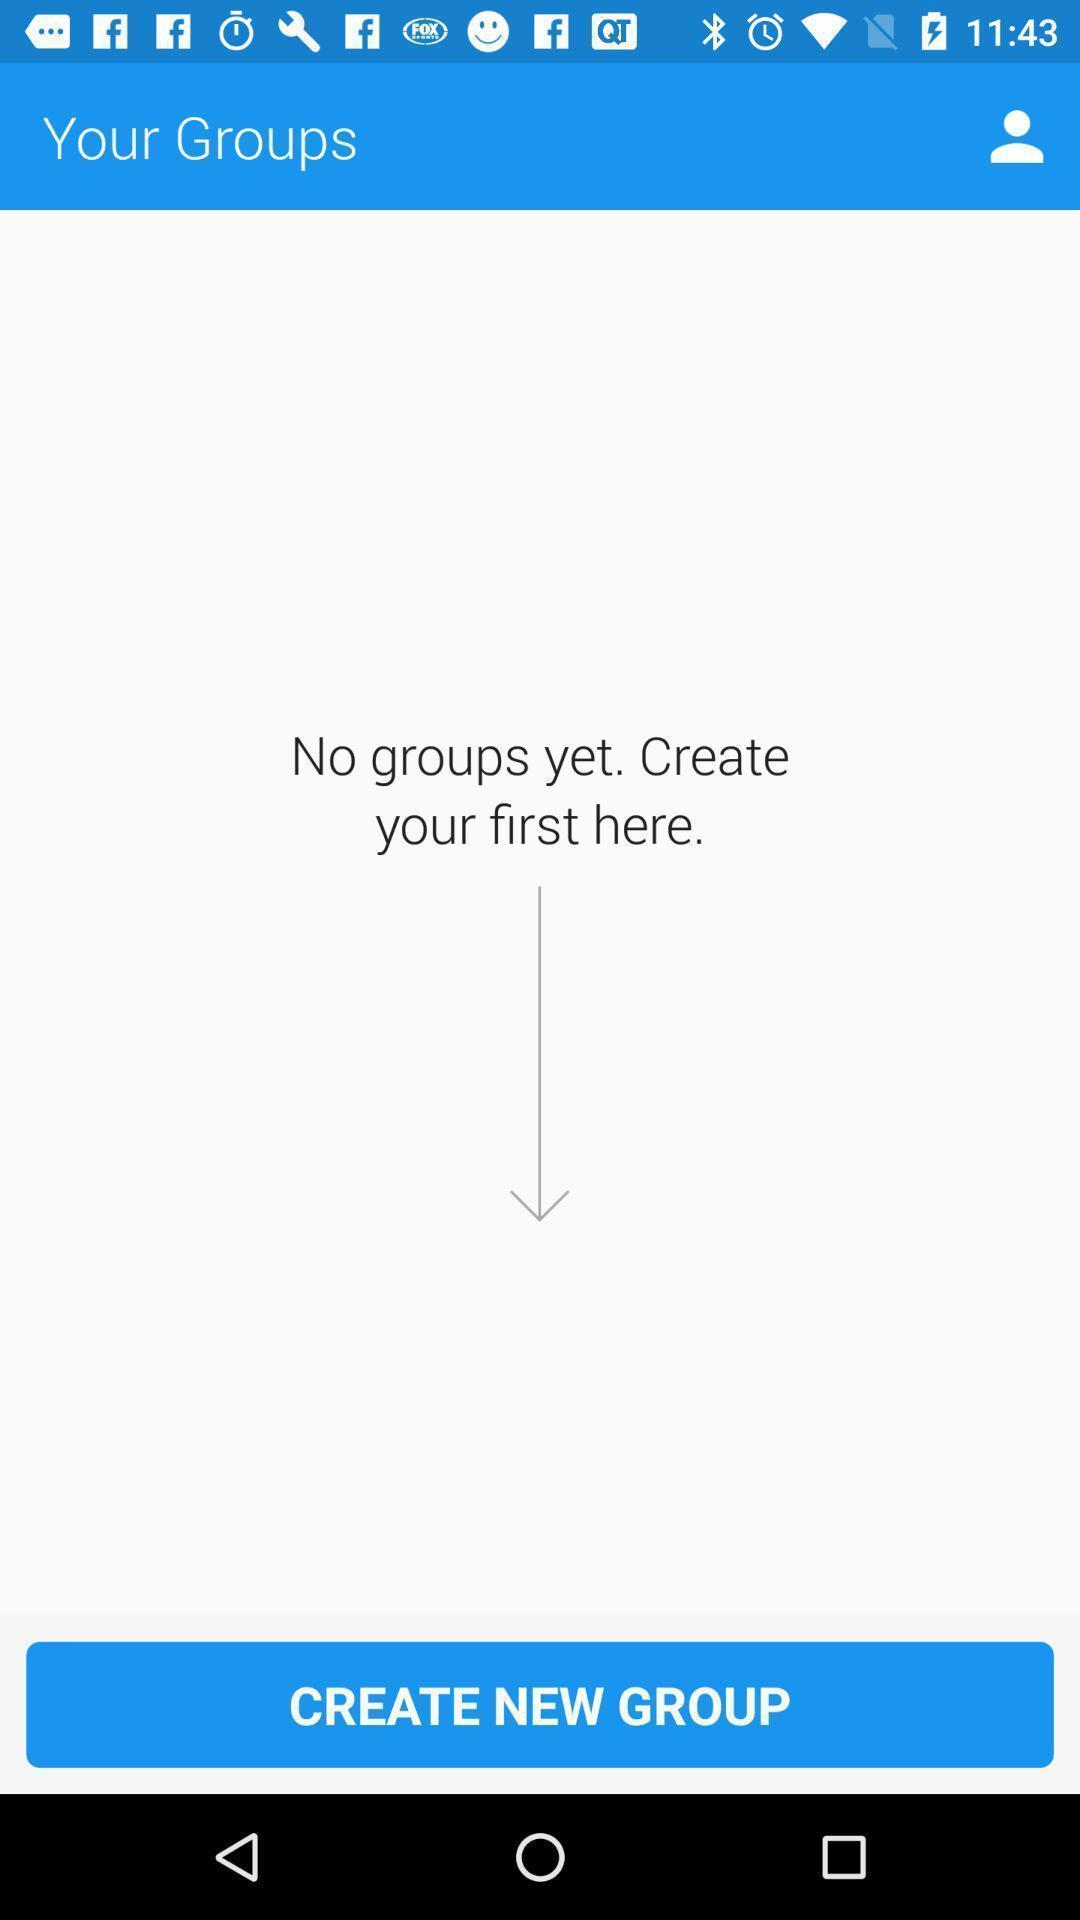Explain the elements present in this screenshot. Screen displaying of no new groups on a mobile device. 